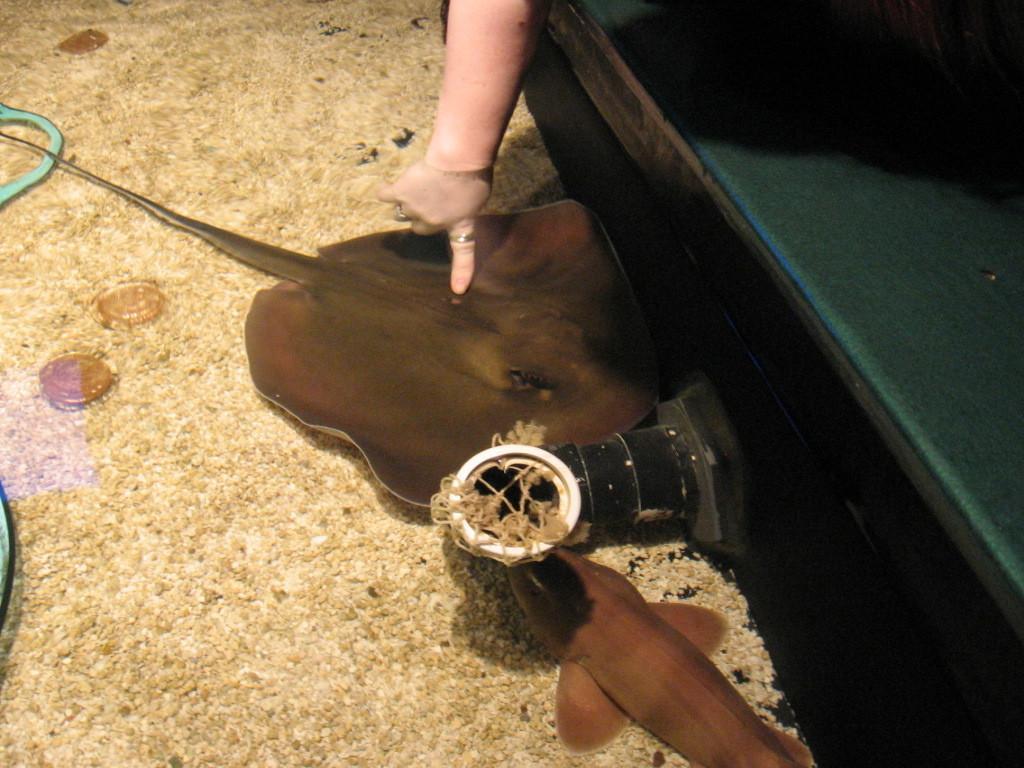Please provide a concise description of this image. This image is taken in the water. At the bottom of the image there are many peoples. There are a few objects. On the right side of the image there is an object, it seems like a table. In the middle of the image there is a ray fish in the water and there is another fish. At the top of the image there is a hand of a person touching a ray fish. 